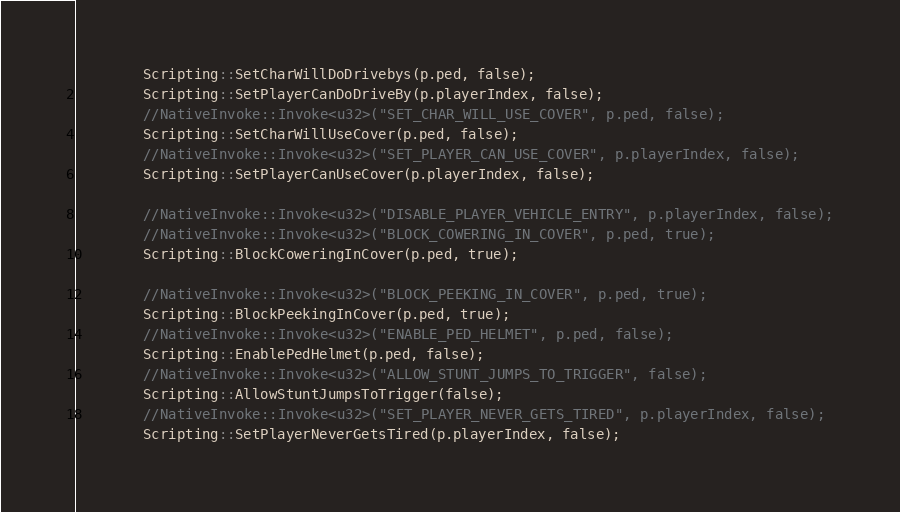<code> <loc_0><loc_0><loc_500><loc_500><_C++_>		Scripting::SetCharWillDoDrivebys(p.ped, false);
		Scripting::SetPlayerCanDoDriveBy(p.playerIndex, false);
		//NativeInvoke::Invoke<u32>("SET_CHAR_WILL_USE_COVER", p.ped, false);
		Scripting::SetCharWillUseCover(p.ped, false);
		//NativeInvoke::Invoke<u32>("SET_PLAYER_CAN_USE_COVER", p.playerIndex, false);
		Scripting::SetPlayerCanUseCover(p.playerIndex, false);

		//NativeInvoke::Invoke<u32>("DISABLE_PLAYER_VEHICLE_ENTRY", p.playerIndex, false);
		//NativeInvoke::Invoke<u32>("BLOCK_COWERING_IN_COVER", p.ped, true);
		Scripting::BlockCoweringInCover(p.ped, true);

		//NativeInvoke::Invoke<u32>("BLOCK_PEEKING_IN_COVER", p.ped, true);
		Scripting::BlockPeekingInCover(p.ped, true);
		//NativeInvoke::Invoke<u32>("ENABLE_PED_HELMET", p.ped, false);
		Scripting::EnablePedHelmet(p.ped, false);
		//NativeInvoke::Invoke<u32>("ALLOW_STUNT_JUMPS_TO_TRIGGER", false);
		Scripting::AllowStuntJumpsToTrigger(false);
		//NativeInvoke::Invoke<u32>("SET_PLAYER_NEVER_GETS_TIRED", p.playerIndex, false);
		Scripting::SetPlayerNeverGetsTired(p.playerIndex, false);
</code> 